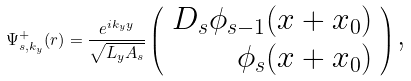Convert formula to latex. <formula><loc_0><loc_0><loc_500><loc_500>\Psi _ { s , k _ { y } } ^ { + } ( { r } ) = \frac { e ^ { i k _ { y } y } } { \sqrt { L _ { y } A _ { s } } } \left ( \begin{array} { r } D _ { s } \phi _ { s - 1 } ( x + x _ { 0 } ) \\ \phi _ { s } ( x + x _ { 0 } ) \end{array} \right ) \text {,}</formula> 